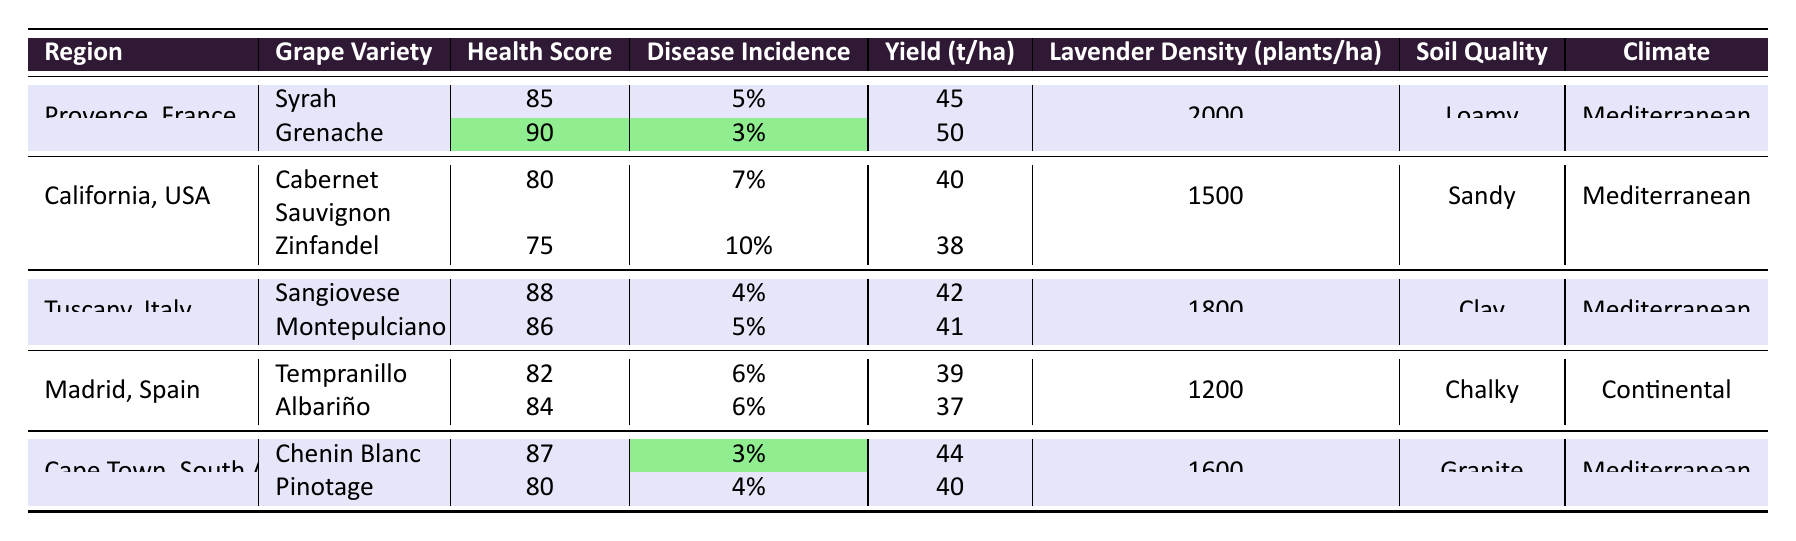What is the health score of Grenache in Provence, France? The table shows that the health score for the Grenache variety in Provence, France is 90.
Answer: 90 What is the disease incidence for Cabernet Sauvignon in California, USA? According to the table, the disease incidence for Cabernet Sauvignon in California, USA is 7%.
Answer: 7% Which region has the highest lavender density? By comparing the lavender density values from each region's data, Provence, France has the highest density at 2000 plants/ha.
Answer: Provence, France What is the average health score of grapevine varieties in Tuscany, Italy? The health scores for Sangiovese and Montepulciano in Tuscany, Italy are 88 and 86, respectively. The average is (88 + 86) / 2 = 87.
Answer: 87 Is the yield per hectare of Zinfandel greater than 40 tons? The yield per hectare for Zinfandel is 38 tons, which is less than 40 tons.
Answer: No What is the total disease incidence percentage for all grape varieties in Cape Town, South Africa? Adding the disease incidence percentages for Chenin Blanc (3%) and Pinotage (4%) gives a total of 3 + 4 = 7%.
Answer: 7% Which grape variety has the lowest health score in the survey? The health score for Zinfandel in California, USA is the lowest at 75.
Answer: Zinfandel If we compare the yield per hectare of the grape varieties in Madrid, Spain, what is the difference between Tempranillo and Albariño? The yield for Tempranillo is 39 tons and for Albariño is 37 tons, so the difference is 39 - 37 = 2 tons.
Answer: 2 tons Does Tuscany, Italy have a greater lavender density than California, USA? Tuscany has a lavender density of 1800 plants/ha, while California's density is 1500 plants/ha. Thus, Tuscany does have a greater density.
Answer: Yes What is the average yield per hectare of all grape varieties in Provence, France? The yields for Syrah and Grenache are 45 and 50 tons, respectively. The average yield is (45 + 50) / 2 = 47.5 tons.
Answer: 47.5 tons 